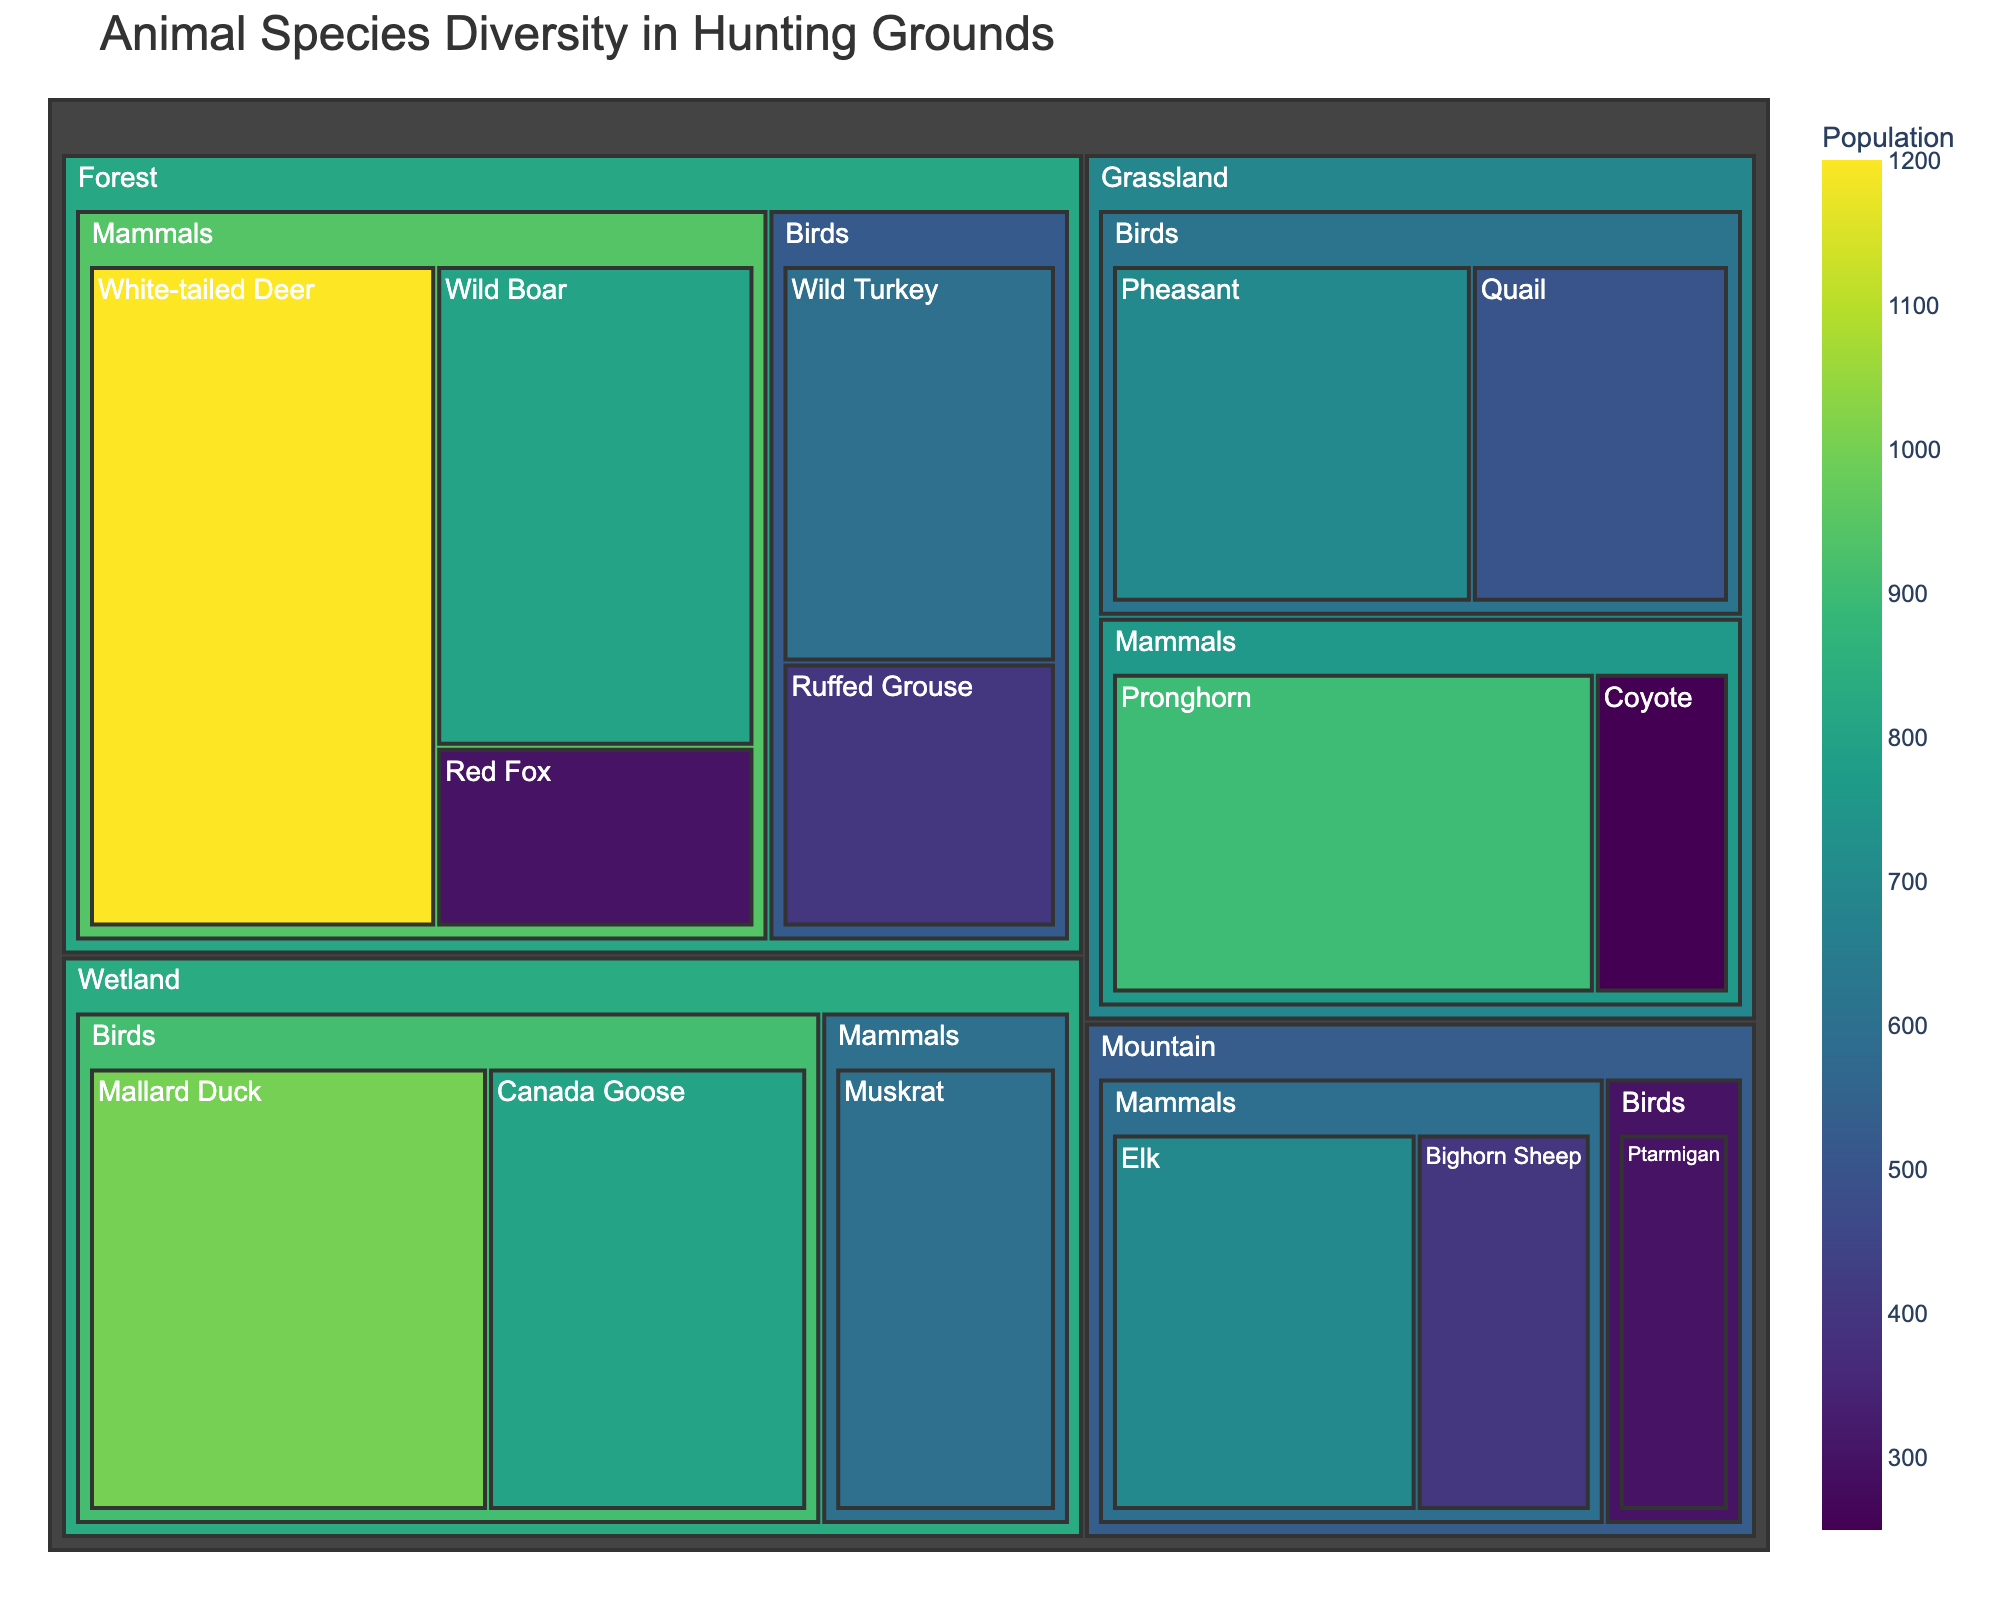How many habitat types are displayed in the treemap? The treemap shows different habitat types within which various animal species are categorized. By identifying distinct root categories in the treemap, you can count the different habitat types present.
Answer: 4 Which animal species has the largest population in the treemap? By observing the areas and labels of each species in the treemap, look for the largest area with the highest population value.
Answer: White-tailed Deer What is the combined population of mammals in the Forest habitat? Filter to the Forest habitat, then sum the populations of White-tailed Deer, Wild Boar, and Red Fox: 1200 + 800 + 300 = 2300.
Answer: 2300 Which bird species in the Grassland habitat has more population, Pheasant or Quail? Compare the sizes of the sections labeled Pheasant and Quail within the Grassland habitat.
Answer: Pheasant What is the difference in population between Elk and Bighorn Sheep in the Mountain habitat? Identify the populations of Elk (700) and Bighorn Sheep (400) in the Mountain habitat and subtract the smaller number from the larger: 700 - 400 = 300.
Answer: 300 How does the overall bird population in the Wetland habitat compare to the overall bird population in the Mountain habitat? Sum the populations of bird species in the Wetland (Mallard Duck: 1000, Canada Goose: 800) and compare to the combined population of birds in the Mountain (Ptarmigan: 300). 1000 + 800 (Wetland) vs. 300 (Mountain).
Answer: Wetland has a higher bird population Which habitat contains the highest population of birds? For each habitat, sum the populations of bird species and compare to determine the habitat with the highest combined bird population: Forest (Wild Turkey: 600, Ruffed Grouse: 400), Grassland (Pheasant: 700, Quail: 500), Wetland (Mallard Duck: 1000, Canada Goose: 800), Mountain (Ptarmigan: 300).
Answer: Wetland What are the populations of mammals compared across all habitat types? Identify and list the populations of mammal species in each habitat: Forest (White-tailed Deer: 1200, Wild Boar: 800, Red Fox: 300), Grassland (Pronghorn: 900, Coyote: 250), Wetland (Muskrat: 600), Mountain (Elk: 700, Bighorn Sheep: 400). Sum for comparison per habitat: Forest (2300), Grassland (1150), Wetland (600), Mountain (1100).
Answer: Forest: 2300, Grassland: 1150, Wetland: 600, Mountain: 1100 